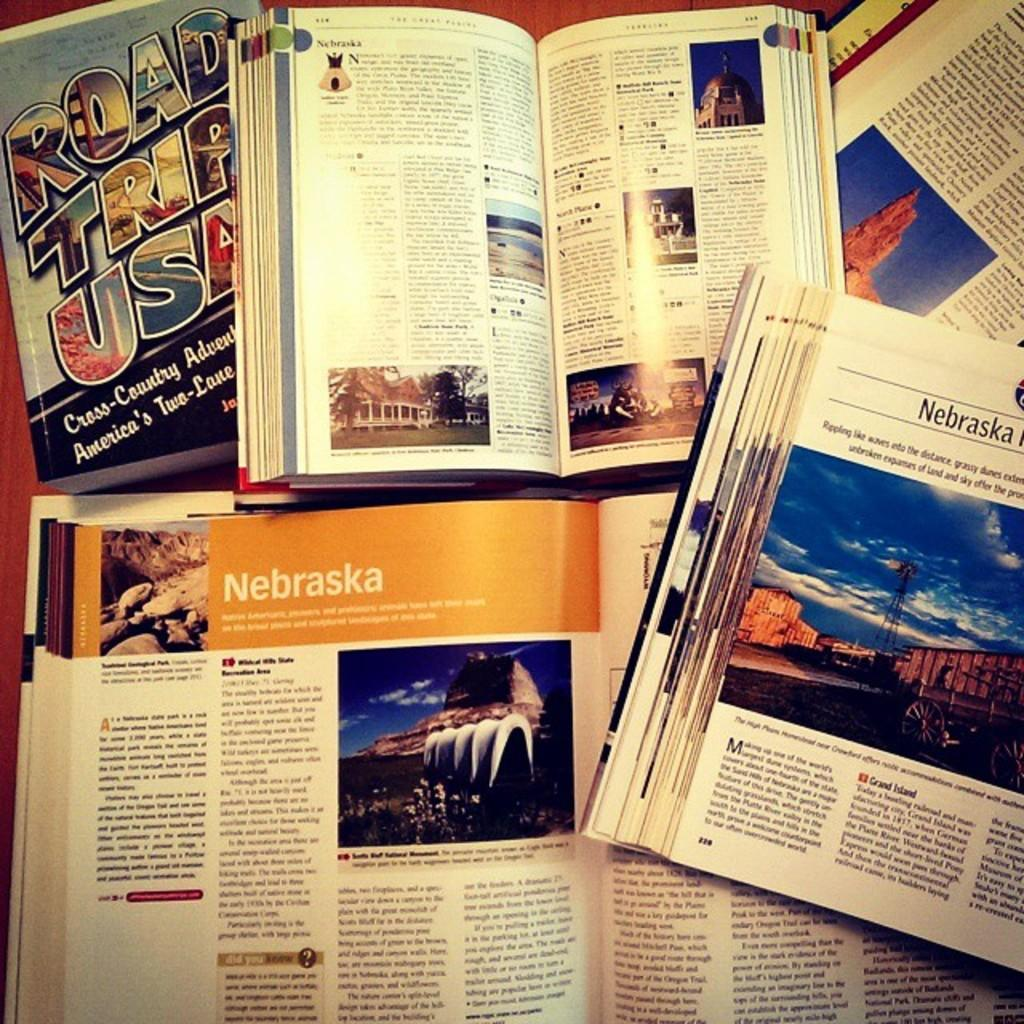<image>
Summarize the visual content of the image. A book titled Road Trip USA is opened to the chapter for the state of Nebraska. 